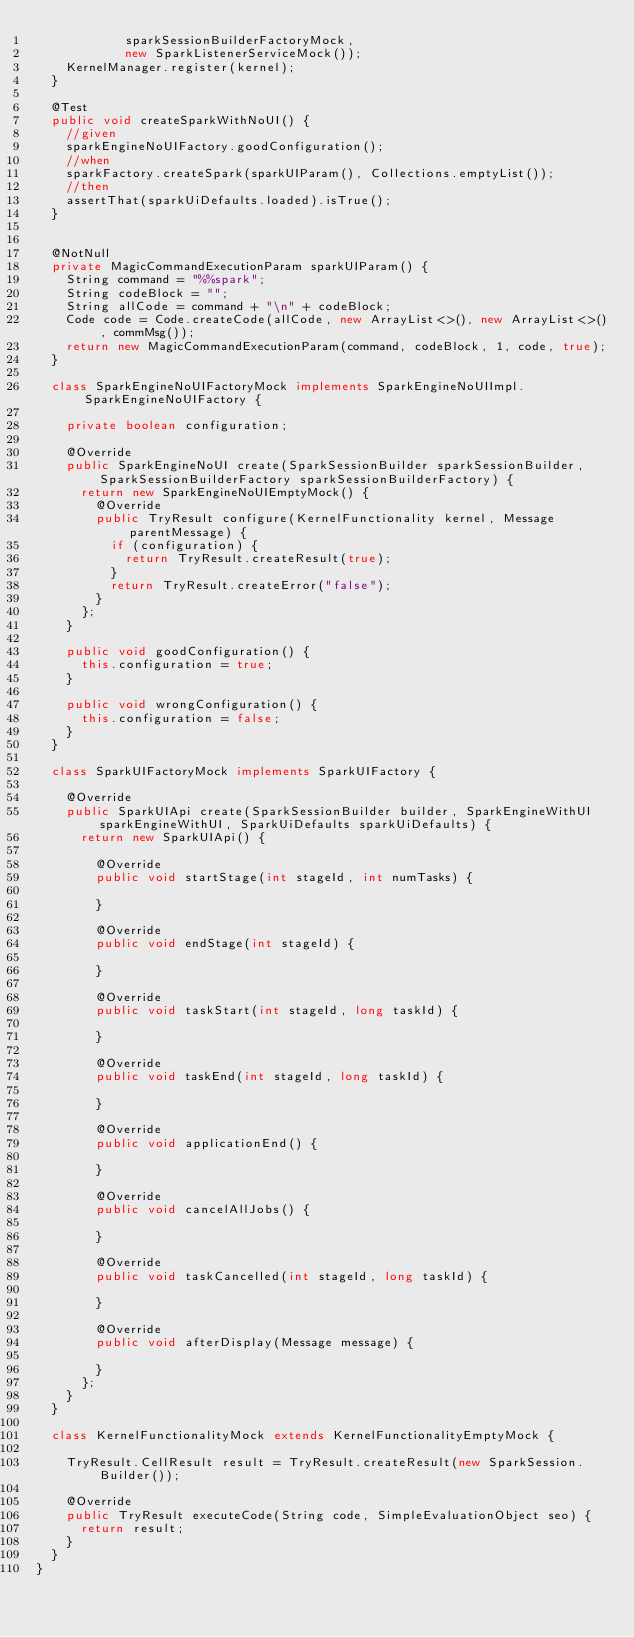<code> <loc_0><loc_0><loc_500><loc_500><_Java_>            sparkSessionBuilderFactoryMock,
            new SparkListenerServiceMock());
    KernelManager.register(kernel);
  }

  @Test
  public void createSparkWithNoUI() {
    //given
    sparkEngineNoUIFactory.goodConfiguration();
    //when
    sparkFactory.createSpark(sparkUIParam(), Collections.emptyList());
    //then
    assertThat(sparkUiDefaults.loaded).isTrue();
  }


  @NotNull
  private MagicCommandExecutionParam sparkUIParam() {
    String command = "%%spark";
    String codeBlock = "";
    String allCode = command + "\n" + codeBlock;
    Code code = Code.createCode(allCode, new ArrayList<>(), new ArrayList<>(), commMsg());
    return new MagicCommandExecutionParam(command, codeBlock, 1, code, true);
  }

  class SparkEngineNoUIFactoryMock implements SparkEngineNoUIImpl.SparkEngineNoUIFactory {

    private boolean configuration;

    @Override
    public SparkEngineNoUI create(SparkSessionBuilder sparkSessionBuilder, SparkSessionBuilderFactory sparkSessionBuilderFactory) {
      return new SparkEngineNoUIEmptyMock() {
        @Override
        public TryResult configure(KernelFunctionality kernel, Message parentMessage) {
          if (configuration) {
            return TryResult.createResult(true);
          }
          return TryResult.createError("false");
        }
      };
    }

    public void goodConfiguration() {
      this.configuration = true;
    }

    public void wrongConfiguration() {
      this.configuration = false;
    }
  }

  class SparkUIFactoryMock implements SparkUIFactory {

    @Override
    public SparkUIApi create(SparkSessionBuilder builder, SparkEngineWithUI sparkEngineWithUI, SparkUiDefaults sparkUiDefaults) {
      return new SparkUIApi() {

        @Override
        public void startStage(int stageId, int numTasks) {

        }

        @Override
        public void endStage(int stageId) {

        }

        @Override
        public void taskStart(int stageId, long taskId) {

        }

        @Override
        public void taskEnd(int stageId, long taskId) {

        }

        @Override
        public void applicationEnd() {

        }

        @Override
        public void cancelAllJobs() {

        }

        @Override
        public void taskCancelled(int stageId, long taskId) {

        }

        @Override
        public void afterDisplay(Message message) {

        }
      };
    }
  }

  class KernelFunctionalityMock extends KernelFunctionalityEmptyMock {

    TryResult.CellResult result = TryResult.createResult(new SparkSession.Builder());

    @Override
    public TryResult executeCode(String code, SimpleEvaluationObject seo) {
      return result;
    }
  }
}</code> 